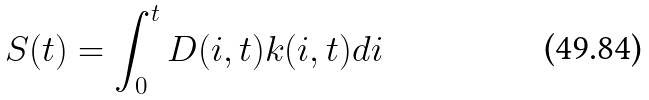<formula> <loc_0><loc_0><loc_500><loc_500>S ( t ) = \int _ { 0 } ^ { t } D ( i , t ) k ( i , t ) d i</formula> 